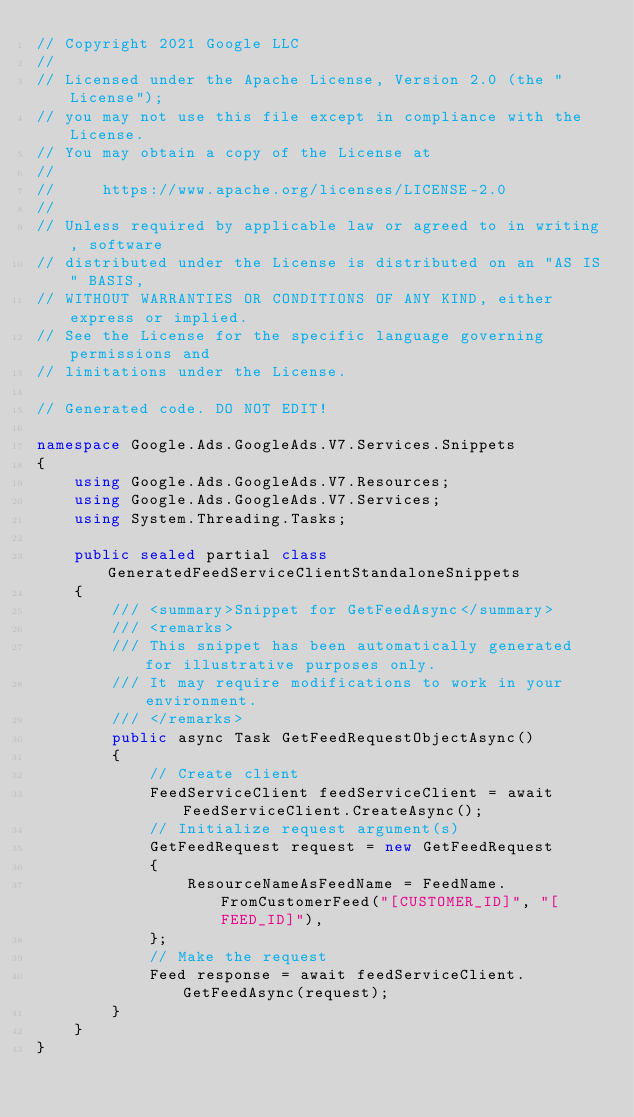Convert code to text. <code><loc_0><loc_0><loc_500><loc_500><_C#_>// Copyright 2021 Google LLC
//
// Licensed under the Apache License, Version 2.0 (the "License");
// you may not use this file except in compliance with the License.
// You may obtain a copy of the License at
//
//     https://www.apache.org/licenses/LICENSE-2.0
//
// Unless required by applicable law or agreed to in writing, software
// distributed under the License is distributed on an "AS IS" BASIS,
// WITHOUT WARRANTIES OR CONDITIONS OF ANY KIND, either express or implied.
// See the License for the specific language governing permissions and
// limitations under the License.

// Generated code. DO NOT EDIT!

namespace Google.Ads.GoogleAds.V7.Services.Snippets
{
    using Google.Ads.GoogleAds.V7.Resources;
    using Google.Ads.GoogleAds.V7.Services;
    using System.Threading.Tasks;

    public sealed partial class GeneratedFeedServiceClientStandaloneSnippets
    {
        /// <summary>Snippet for GetFeedAsync</summary>
        /// <remarks>
        /// This snippet has been automatically generated for illustrative purposes only.
        /// It may require modifications to work in your environment.
        /// </remarks>
        public async Task GetFeedRequestObjectAsync()
        {
            // Create client
            FeedServiceClient feedServiceClient = await FeedServiceClient.CreateAsync();
            // Initialize request argument(s)
            GetFeedRequest request = new GetFeedRequest
            {
                ResourceNameAsFeedName = FeedName.FromCustomerFeed("[CUSTOMER_ID]", "[FEED_ID]"),
            };
            // Make the request
            Feed response = await feedServiceClient.GetFeedAsync(request);
        }
    }
}
</code> 